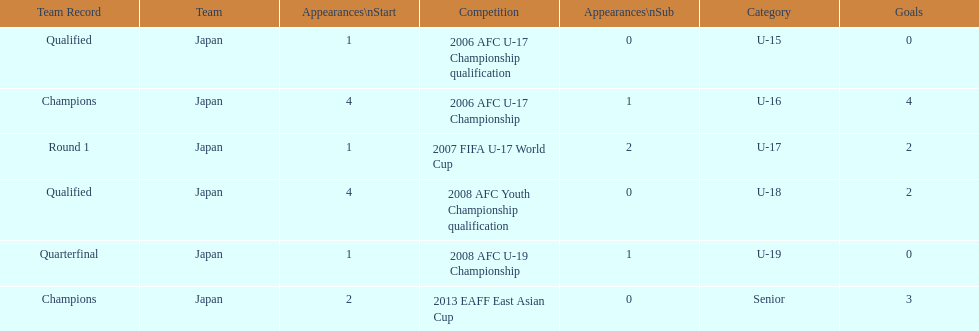How many total goals were scored? 11. 